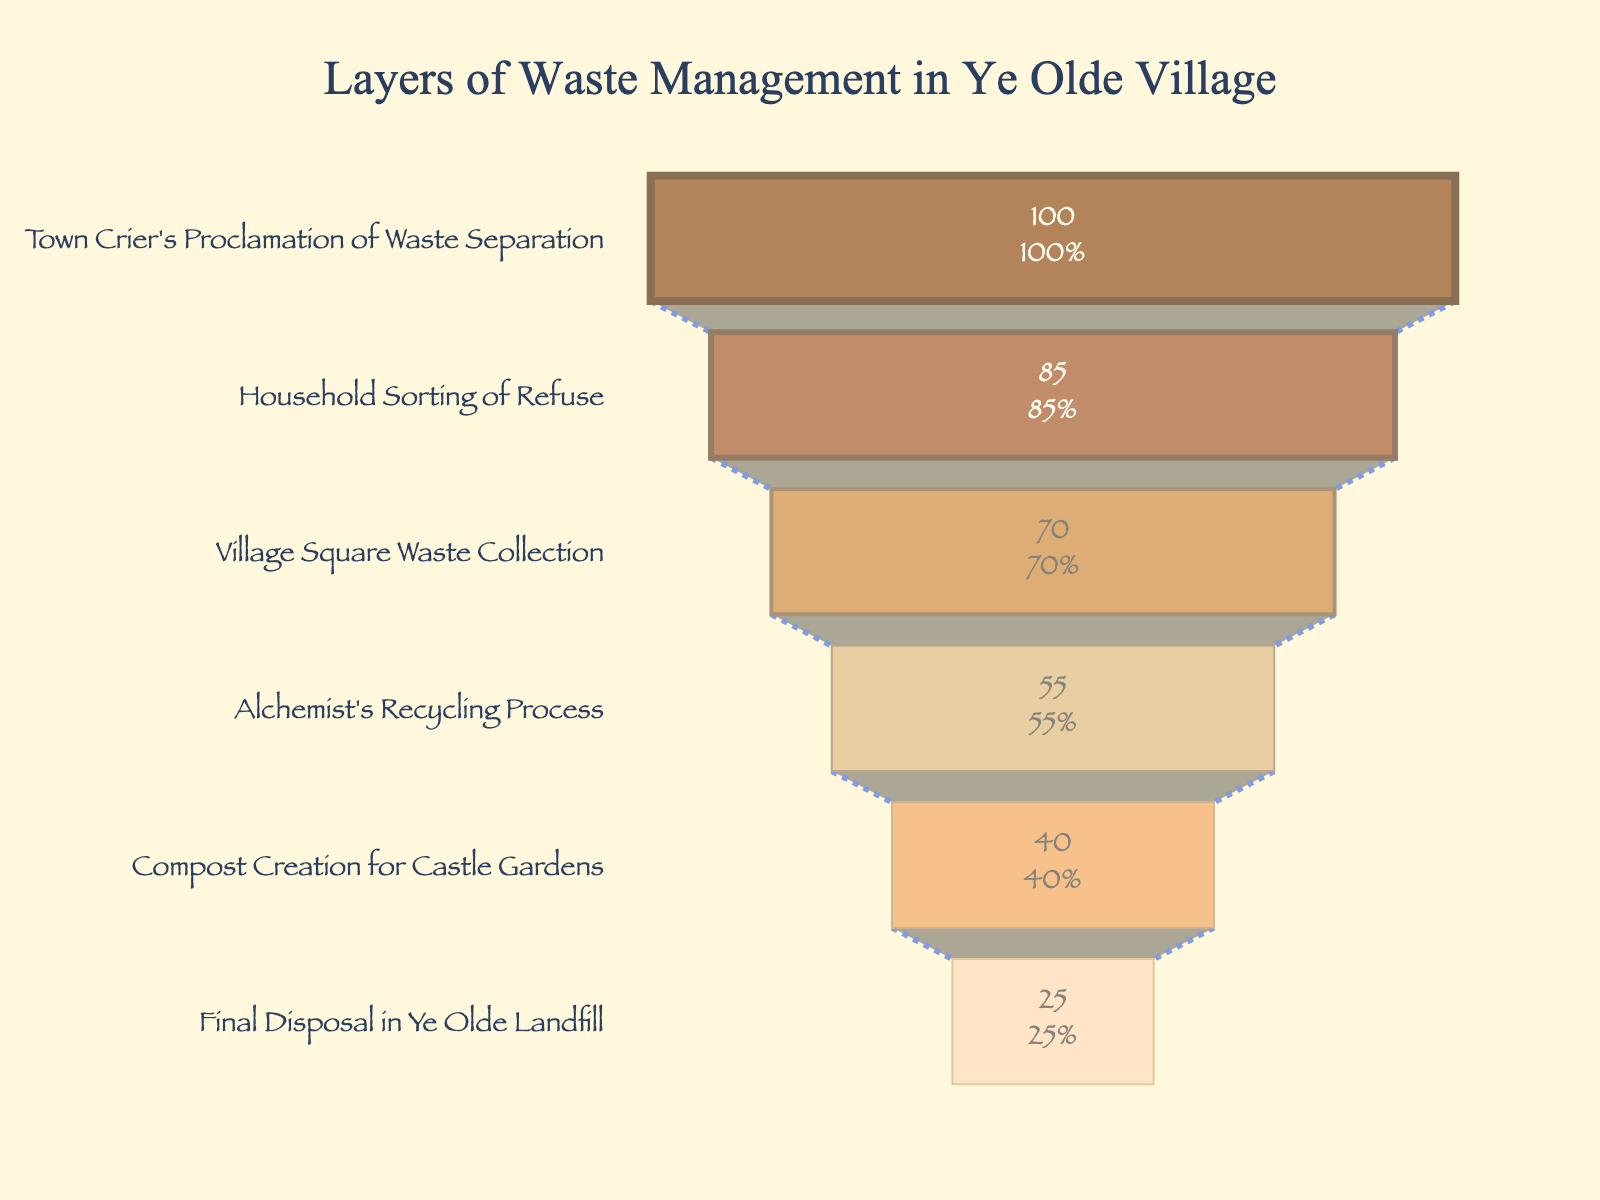What is the title of the figure? The title of the figure is at the top and is typically designed to give an overview of what the chart represents. Here, it reads, "Layers of Waste Management in Ye Olde Village."
Answer: Layers of Waste Management in Ye Olde Village How many stages are there in the waste management process? To find the number of stages, one must count the unique entries in the "Stage" axis of the funnel chart. In this case, there are six stages.
Answer: 6 Which stage of waste management has the highest percentage? The funnel chart typically has the highest percentage at the top stage. Here, it is "Town Crier's Proclamation of Waste Separation" with 100%.
Answer: Town Crier's Proclamation of Waste Separation What is the final disposal stage percentage? Moving from the top to the bottom of the funnel chart, the final stage is listed as "Final Disposal in Ye Olde Landfill" with 25%.
Answer: 25% What is the percentage difference between the "Village Square Waste Collection" and the "Household Sorting of Refuse"? According to the chart, the percentages for "Village Square Waste Collection" and "Household Sorting of Refuse" are 70% and 85%, respectively. The difference is 85% - 70% = 15%.
Answer: 15% Which stage has the lower percentage: "Compost Creation for Castle Gardens" or "Alchemist's Recycling Process"? Comparing the two stages, the "Compost Creation for Castle Gardens" has a lower percentage (40%) than the "Alchemist's Recycling Process" (55%).
Answer: Compost Creation for Castle Gardens What is the cumulative percentage of the first three stages? The first three stages are "Town Crier's Proclamation of Waste Separation" (100%), "Household Sorting of Refuse" (85%), and "Village Square Waste Collection" (70%). Summing these, 100% + 85% + 70% = 255%.
Answer: 255% What is the average percentage of all the stages? To find the average, sum the percentages of all six stages: 100% + 85% + 70% + 55% + 40% + 25% = 375%. Dividing by the number of stages (6), the average percentage is 375% / 6 ≈ 62.5%.
Answer: 62.5% Does the "Alchemist's Recycling Process" retain more than half of the initial waste? According to the chart, the "Alchemist's Recycling Process" retains 55% of the waste, which is indeed more than half of the initial 100% waste.
Answer: Yes Explain how the funnel shape represents the waste management process. A funnel chart visually demonstrates the decreasing quantity of waste as it progresses through stages. The top represents the initial amount, the wider open end, and as waste gets processed, the percentage reduces, leading to a narrower lower end, indicating minimized waste remaining.
Answer: The funnel shape shows the reduction in waste through stages 